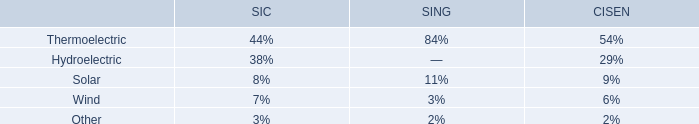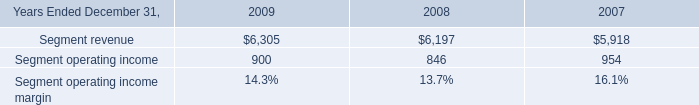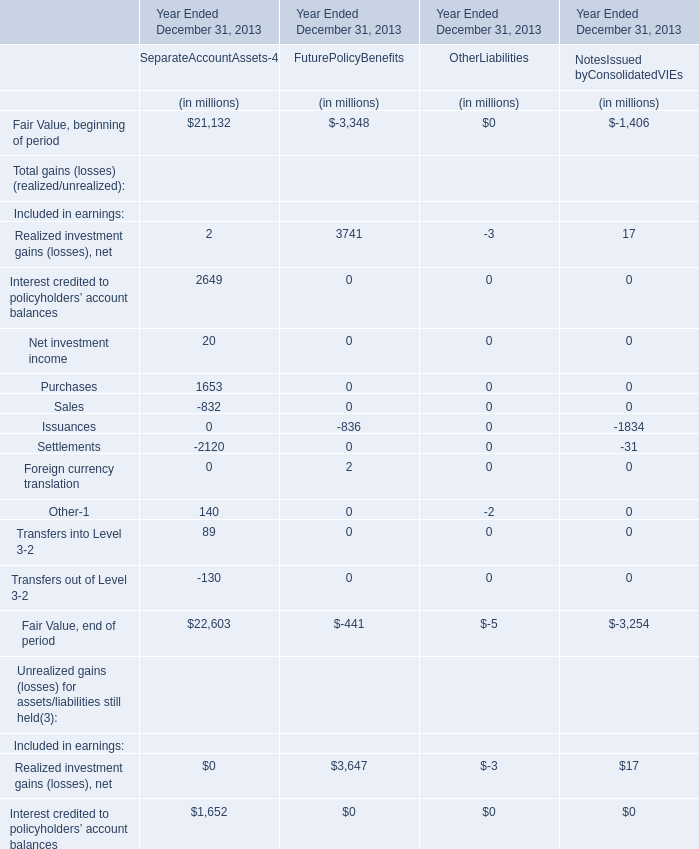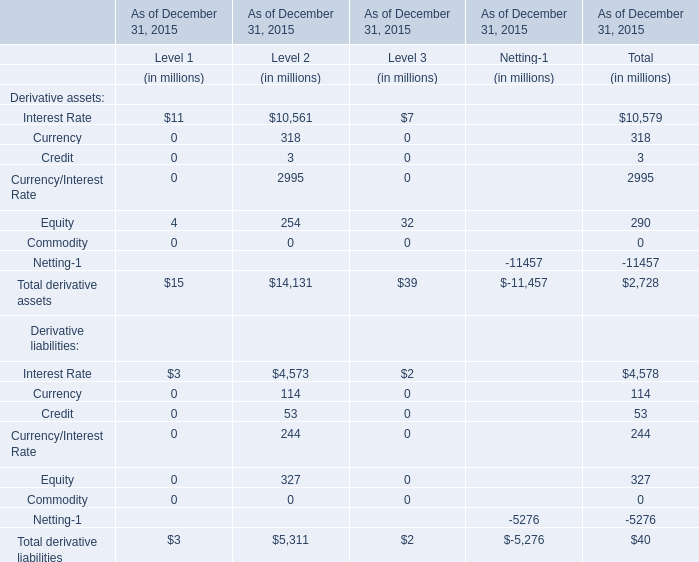Among Level 1-3,what is the highest value of Total derivative assets as of December 31, 2015? (in million) 
Answer: 14131. what was the percent of the change in the risk and insurance brokerage services segment revenue from 2008 2009\\n 
Computations: ((6305 - 6197) / 6197)
Answer: 0.01743. 